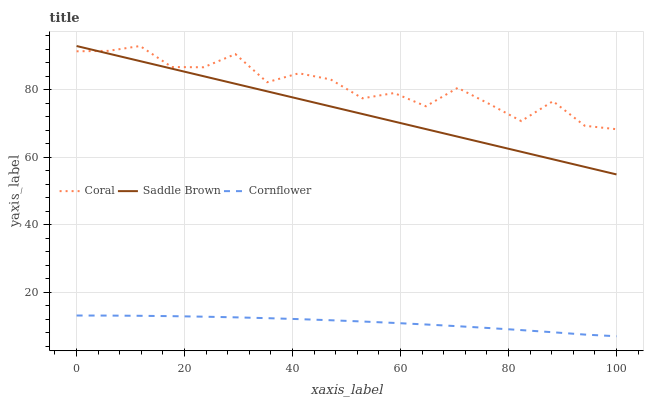Does Cornflower have the minimum area under the curve?
Answer yes or no. Yes. Does Coral have the maximum area under the curve?
Answer yes or no. Yes. Does Saddle Brown have the minimum area under the curve?
Answer yes or no. No. Does Saddle Brown have the maximum area under the curve?
Answer yes or no. No. Is Saddle Brown the smoothest?
Answer yes or no. Yes. Is Coral the roughest?
Answer yes or no. Yes. Is Coral the smoothest?
Answer yes or no. No. Is Saddle Brown the roughest?
Answer yes or no. No. Does Saddle Brown have the lowest value?
Answer yes or no. No. Is Cornflower less than Saddle Brown?
Answer yes or no. Yes. Is Coral greater than Cornflower?
Answer yes or no. Yes. Does Cornflower intersect Saddle Brown?
Answer yes or no. No. 